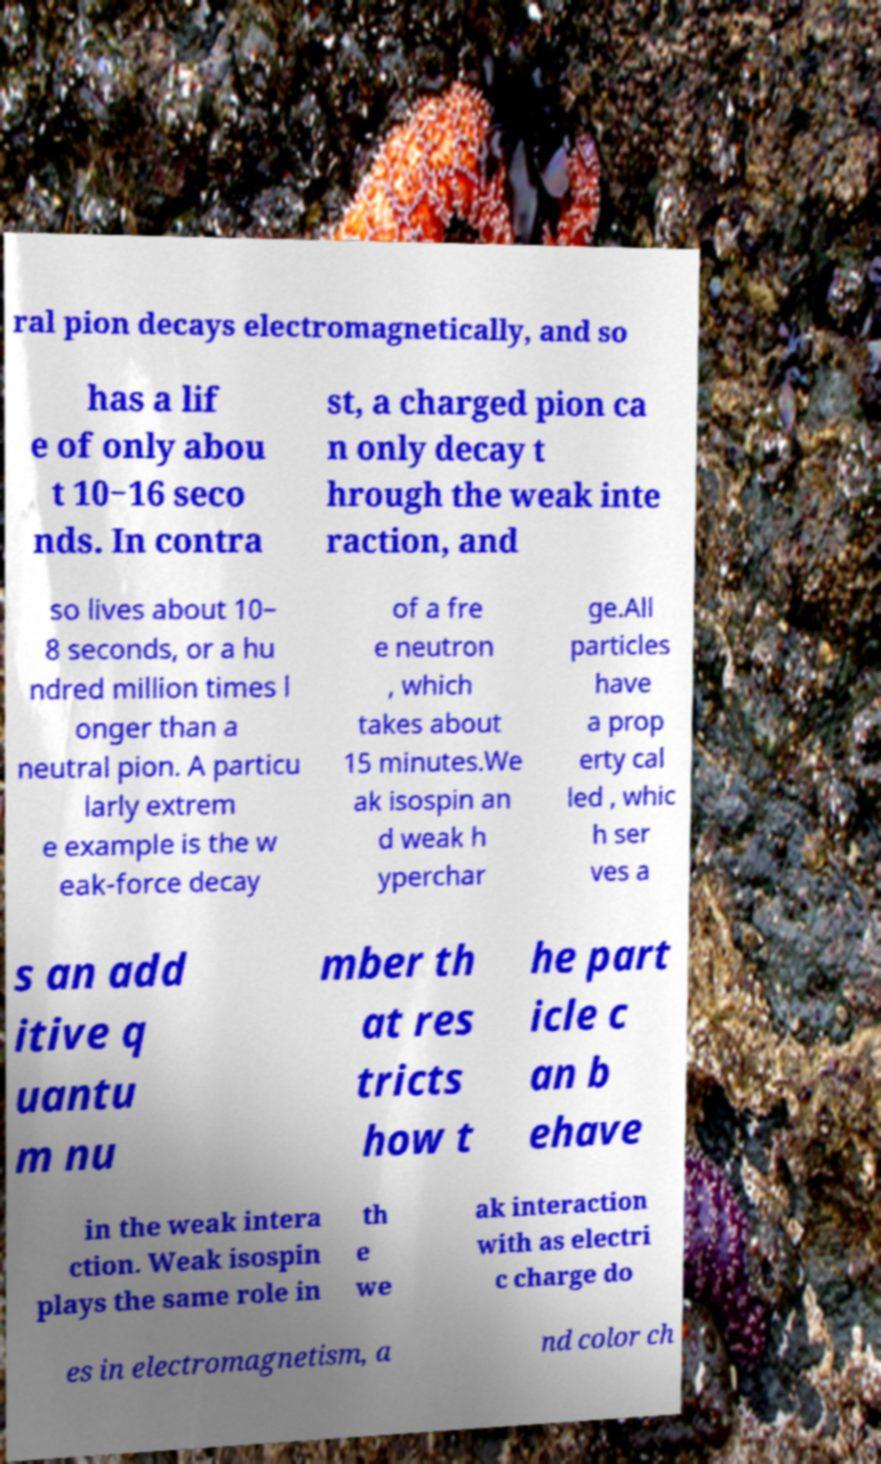Could you extract and type out the text from this image? ral pion decays electromagnetically, and so has a lif e of only abou t 10−16 seco nds. In contra st, a charged pion ca n only decay t hrough the weak inte raction, and so lives about 10− 8 seconds, or a hu ndred million times l onger than a neutral pion. A particu larly extrem e example is the w eak-force decay of a fre e neutron , which takes about 15 minutes.We ak isospin an d weak h yperchar ge.All particles have a prop erty cal led , whic h ser ves a s an add itive q uantu m nu mber th at res tricts how t he part icle c an b ehave in the weak intera ction. Weak isospin plays the same role in th e we ak interaction with as electri c charge do es in electromagnetism, a nd color ch 